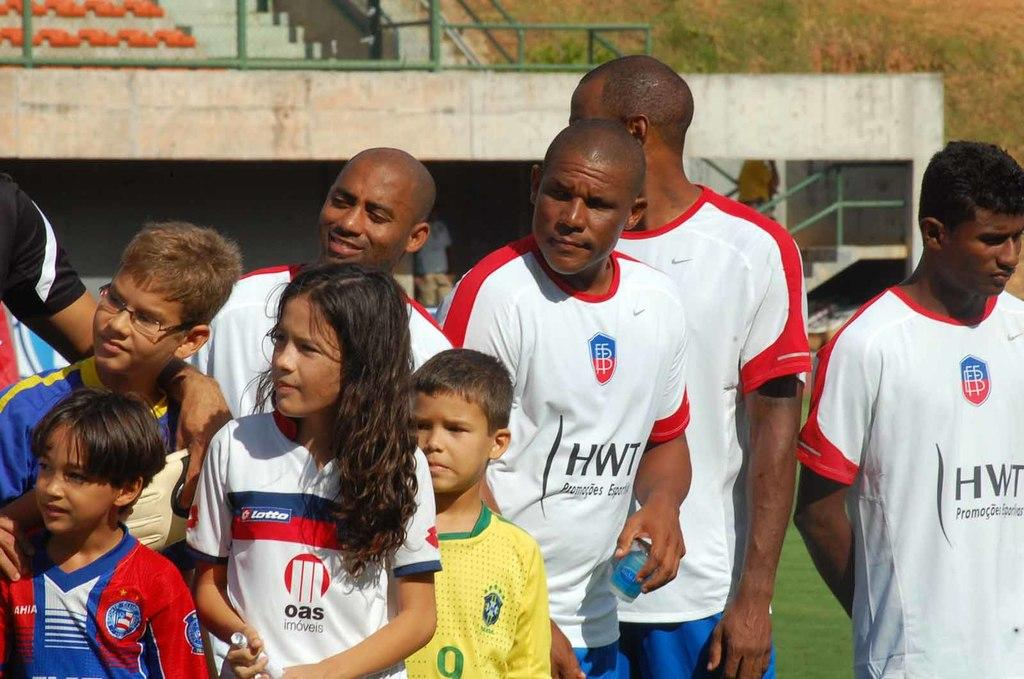<image>
Provide a brief description of the given image. Children are posing with people wearing HWT shirts. 